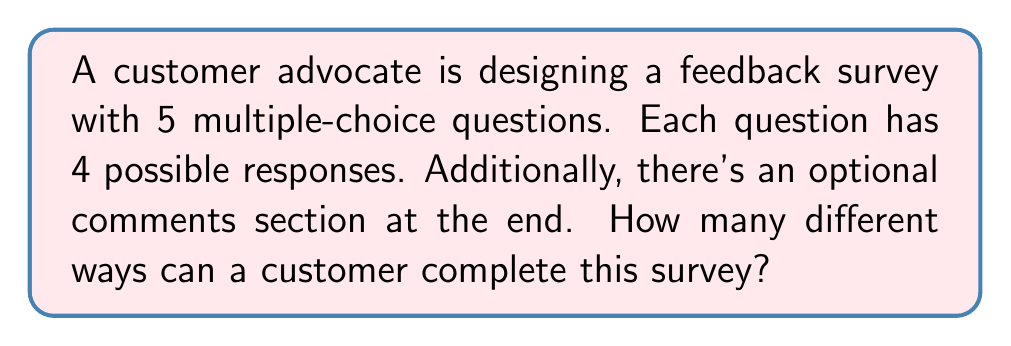Teach me how to tackle this problem. Let's approach this step-by-step:

1) First, let's consider the multiple-choice questions:
   - There are 5 questions
   - Each question has 4 possible responses

   For each question, the customer has 4 choices. This is repeated for all 5 questions.
   Therefore, the number of ways to answer the multiple-choice section is:

   $$ 4^5 = 1024 $$

2) Now, let's consider the optional comments section:
   - The customer can either leave a comment or not
   - This is essentially a binary choice

   We can represent this as 2 possibilities:

   $$ 2^1 = 2 $$

3) To find the total number of ways to complete the survey, we multiply these together:

   $$ 4^5 \times 2^1 = 1024 \times 2 = 2048 $$

This multiplication is valid because for each way of answering the multiple-choice questions, there are 2 possibilities for the comments section (leave a comment or not).
Answer: 2048 